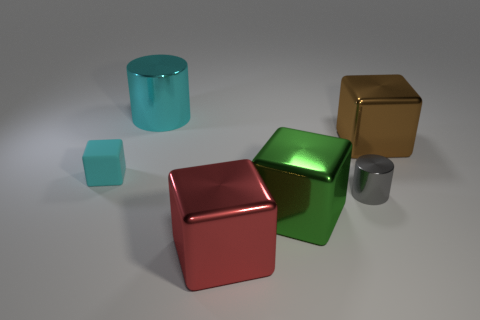What number of large cyan rubber objects are there? There is one large cyan rubber object visible in the image, which is a cylinder shape. 